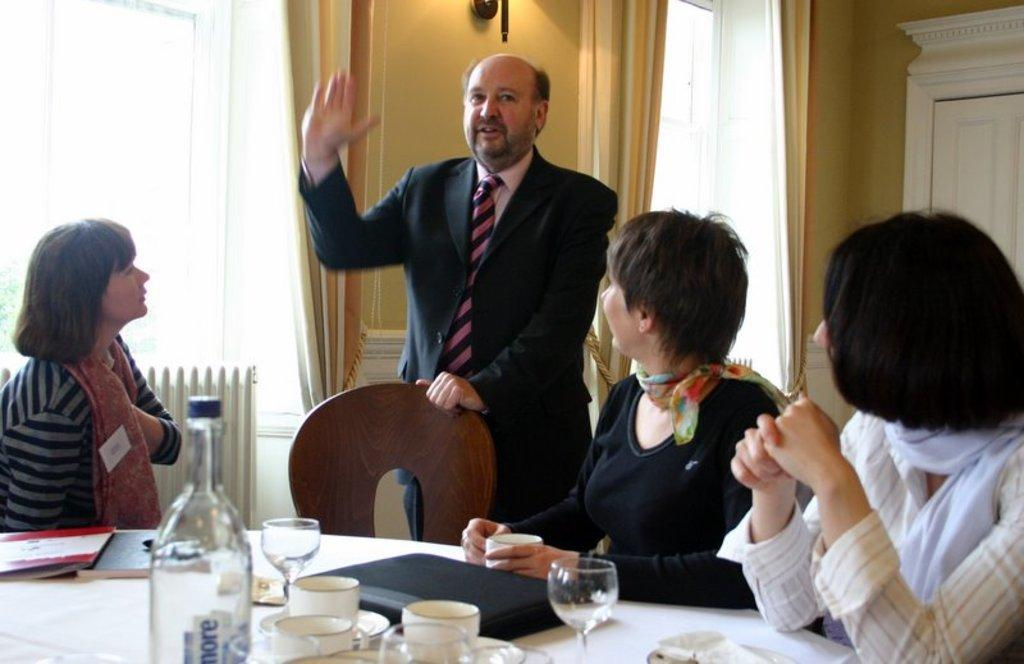What are the people in the image doing? The people in the image are sitting on chairs. Is there anyone standing in the image? Yes, there is a man standing in the image. What furniture is present in the image? There is a table in the image. What items can be seen on the table? There is a bottle, a wine glass, a cup, and a soccer-related item on the table. Can you tell me what book the goose is reading on the island in the image? There is no book, goose, or island present in the image. 